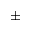Convert formula to latex. <formula><loc_0><loc_0><loc_500><loc_500>\pm</formula> 